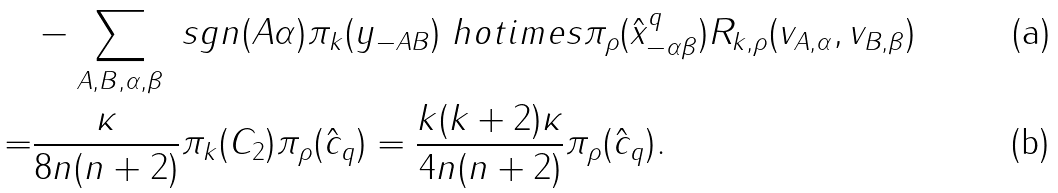Convert formula to latex. <formula><loc_0><loc_0><loc_500><loc_500>& - \sum _ { A , B , \alpha , \beta } \ s g n ( A \alpha ) \pi _ { k } ( y _ { - A B } ) \ h o t i m e s \pi _ { \rho } ( \hat { x } _ { - \alpha \beta } ^ { q } ) R _ { k , \rho } ( v _ { A , \alpha } , v _ { B , \beta } ) \\ = & \frac { \kappa } { 8 n ( n + 2 ) } \pi _ { k } ( C _ { 2 } ) \pi _ { \rho } ( \hat { c } _ { q } ) = \frac { k ( k + 2 ) \kappa } { 4 n ( n + 2 ) } \pi _ { \rho } ( \hat { c } _ { q } ) .</formula> 